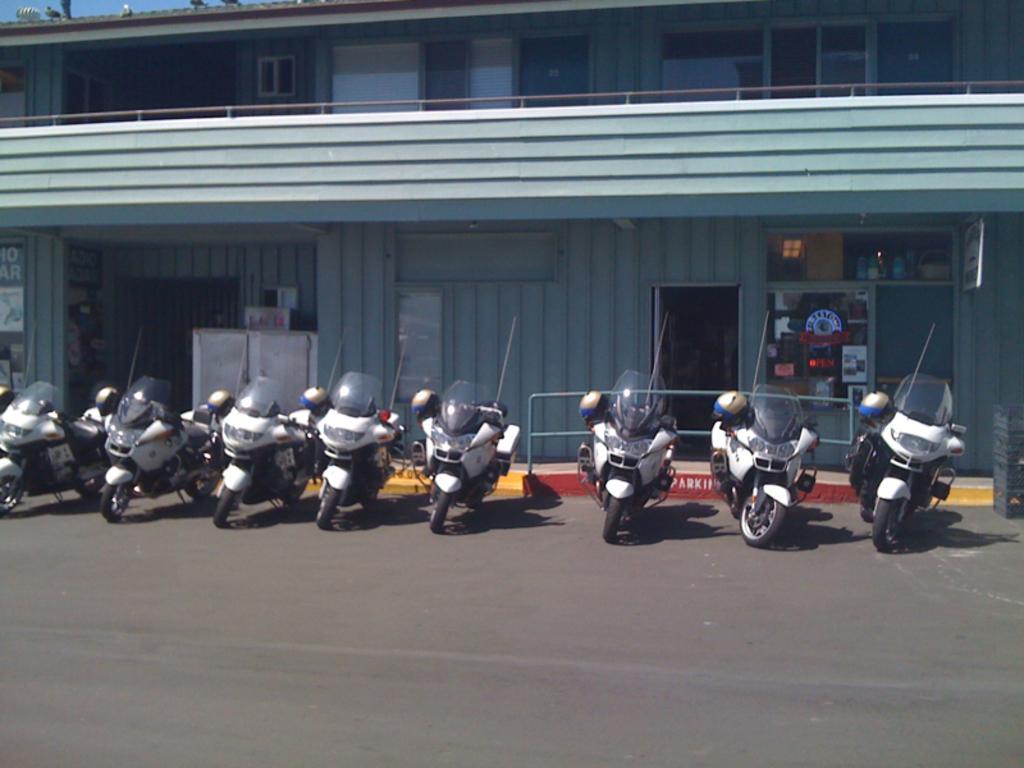In one or two sentences, can you explain what this image depicts? In this image we can see many bikes on the road. In the background we can see building, doors, windows, birds and sky. 